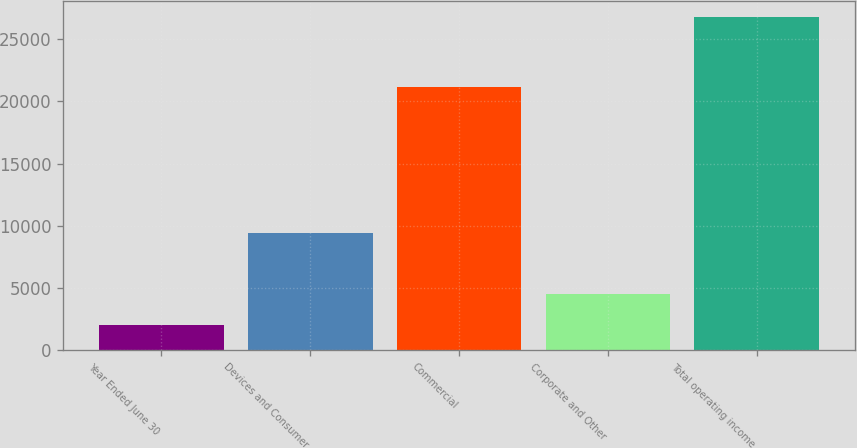<chart> <loc_0><loc_0><loc_500><loc_500><bar_chart><fcel>Year Ended June 30<fcel>Devices and Consumer<fcel>Commercial<fcel>Corporate and Other<fcel>Total operating income<nl><fcel>2013<fcel>9421<fcel>21132<fcel>4488.1<fcel>26764<nl></chart> 